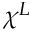<formula> <loc_0><loc_0><loc_500><loc_500>\chi ^ { L }</formula> 